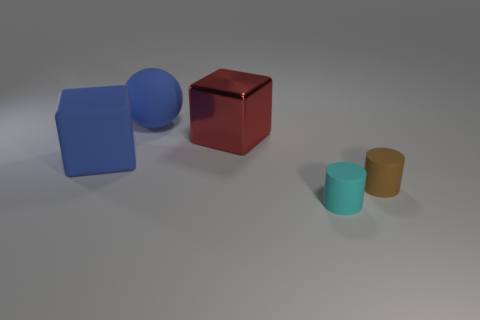Are any small blue matte things visible?
Give a very brief answer. No. The blue thing that is made of the same material as the blue sphere is what size?
Your response must be concise. Large. Is the brown cylinder made of the same material as the red thing?
Your answer should be compact. No. What number of other objects are there of the same material as the big blue ball?
Ensure brevity in your answer.  3. How many rubber objects are both in front of the big blue matte ball and behind the tiny cyan cylinder?
Offer a very short reply. 2. The matte ball is what color?
Make the answer very short. Blue. What material is the other small object that is the same shape as the tiny cyan matte object?
Your answer should be compact. Rubber. Are there any other things that are the same material as the large red block?
Keep it short and to the point. No. Is the large rubber cube the same color as the big sphere?
Offer a very short reply. Yes. The blue matte object that is in front of the big sphere on the left side of the small cyan matte object is what shape?
Offer a very short reply. Cube. 